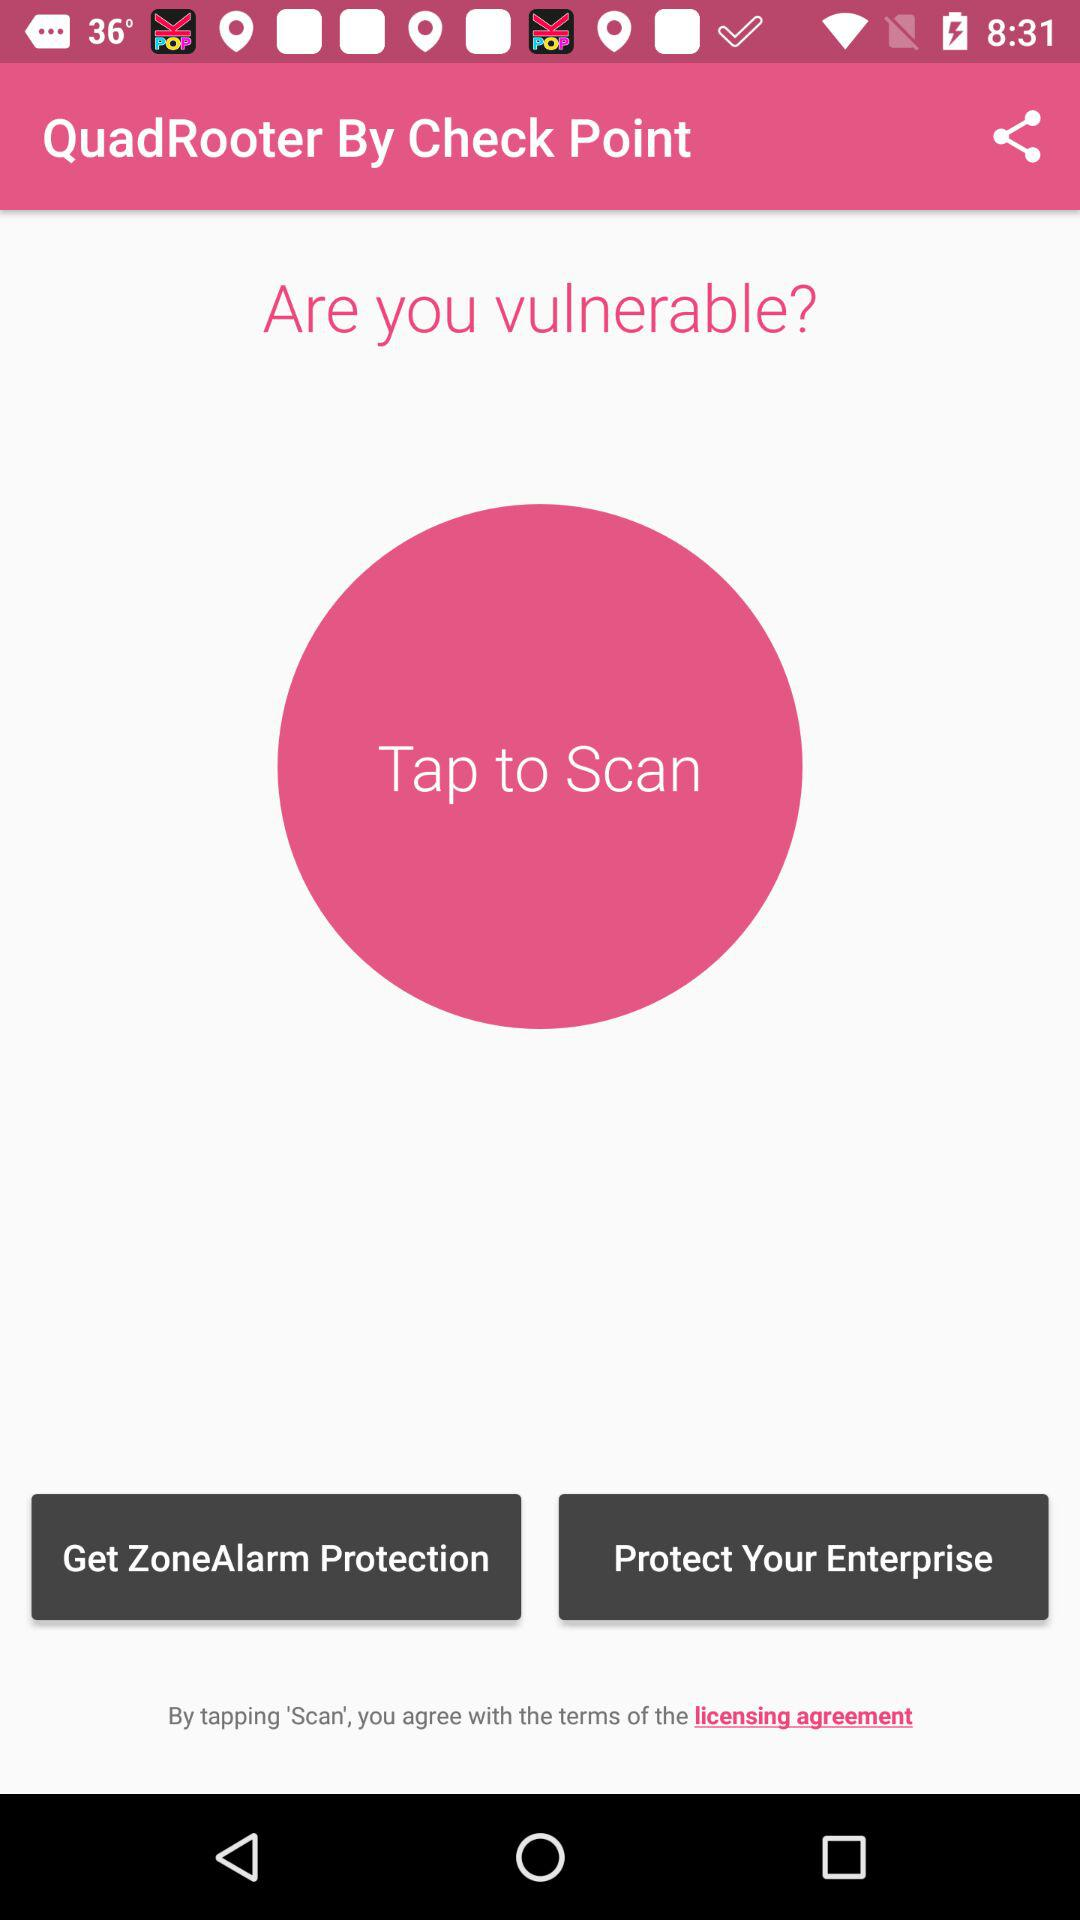What is the app name? The app name is "QuadRooter". 